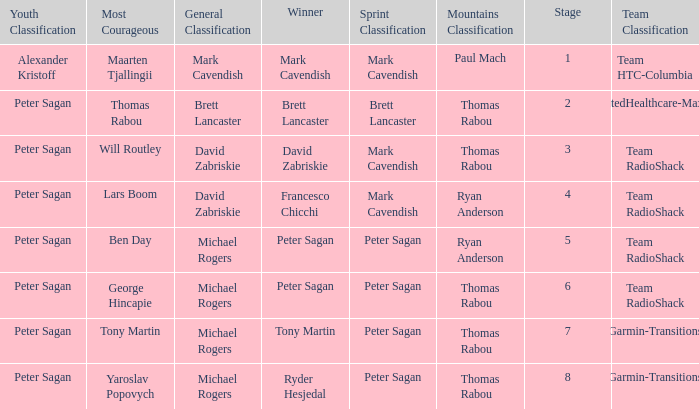When Mark Cavendish wins sprint classification and Maarten Tjallingii wins most courageous, who wins youth classification? Alexander Kristoff. 